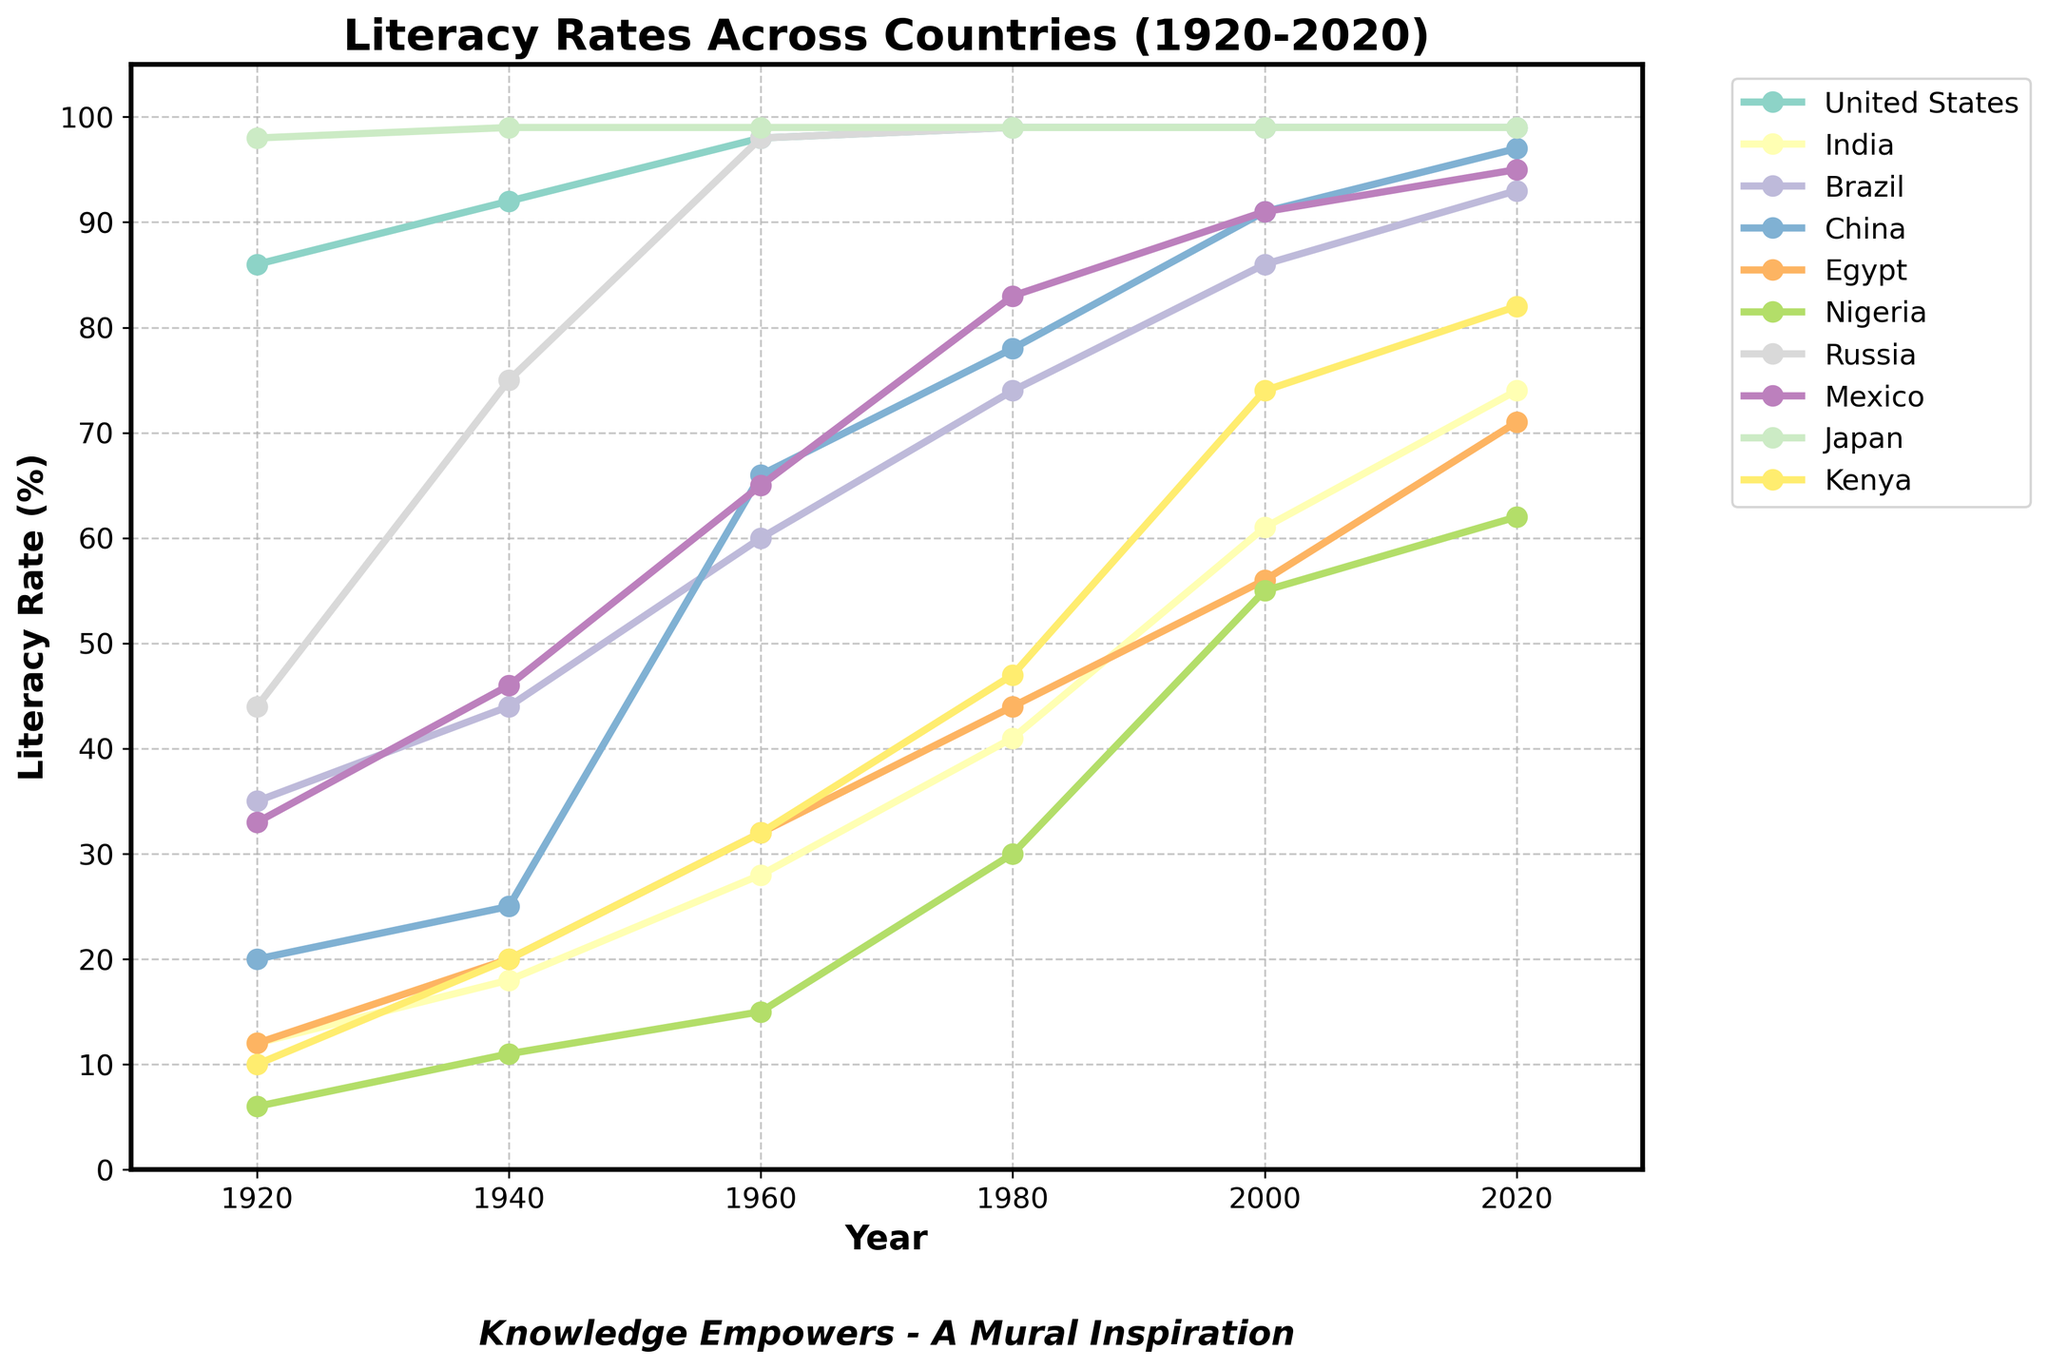Which country had the highest literacy rate in 1920? The chart shows multiple countries with their literacy rates over the years. For 1920, looking for the highest value among the countries, Japan has the highest rate at 98%.
Answer: Japan Which country experienced the greatest improvement in literacy rate from 1920 to 2020? Compare the differences between 1920 and 2020 literacy rates for each country: United States (99-86), India (74-12), Brazil (93-35), China (97-20), Egypt (71-12), Nigeria (62-6), Russia (99-44), Mexico (95-33), Japan (99-98), Kenya (82-10). India had the greatest improvement with an increase of 62 percentage points.
Answer: India Which countries reached a literacy rate of 99% by 2020? Look at the literacy rates for the year 2020. United States, Russia, and Japan all have a literacy rate of 99%.
Answer: United States, Russia, Japan How did Brazil's literacy rate in 1960 compare to that of Mexico in the same year? Look at the values for Brazil and Mexico in 1960. Brazil had a rate of 60%, whereas Mexico had a rate of 65%. So, Mexico was higher by 5 percentage points.
Answer: Mexico's was higher by 5 percentage points Between 1940 and 1980, which country saw a decrease in its literacy rate? Examine the lines for each country to see if any literacy rate decreases between 1940 and 1980. No country experienced a decrease; all lines are either flat or increasing. Therefore, no country saw a decrease.
Answer: None What's the average literacy rate of India, China, and Brazil in 2020? Sum the literacy rates of India (74), China (97), and Brazil (93) in 2020 and divide by 3: (74 + 97 + 93) / 3 = 88.
Answer: 88 Which country's literacy rate was closest to the global average (simple average of all countries listed) in 2000? Calculate the global average for 2000 by summing the rates of all countries and dividing by 10: (99 + 61 + 86 + 91 + 56 + 55 + 99 + 91 + 99 + 74) / 10 = 81.1. Compare with individual rates to find the closest. The closest country is Brazil at 86.
Answer: Brazil How did the literacy rates of India and Egypt compare in 1980? Compare the values for India and Egypt in 1980. India's rate was 41%, and Egypt's rate was 44%. Egypt's literacy rate was 3 percentage points higher than India's.
Answer: Egypt's was higher by 3 points Which country achieved a literacy rate of 90% the earliest according to the chart? Find when each country reached 90% by examining the plotted lines. China reached 91% in 2000, Mexico reached 91% in 2000, but from the earlier point, it's Russia, which had 98% already by 1960.
Answer: Russia 